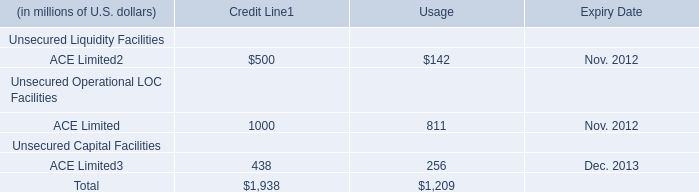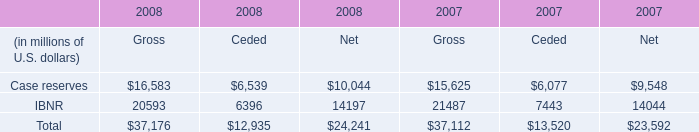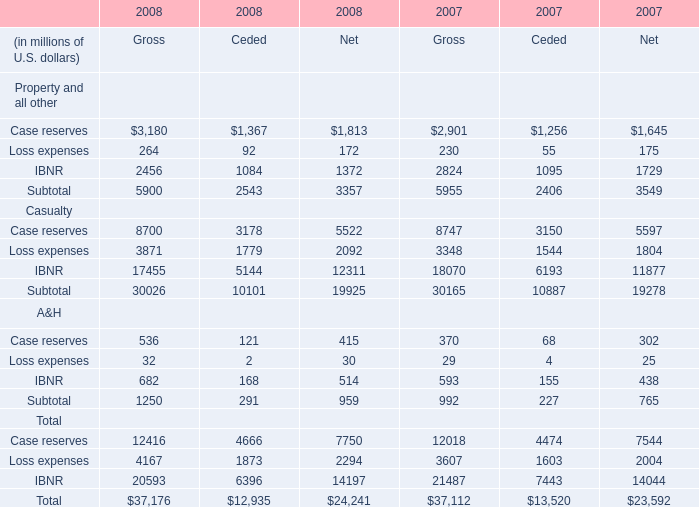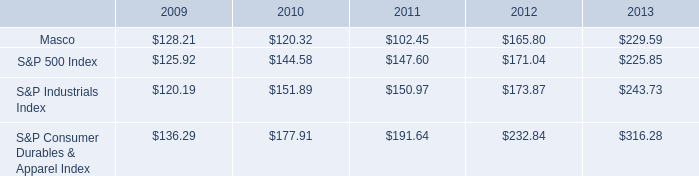What's the growth rate of IBNR of A&H of Gross in 2008? 
Computations: ((682 - 593) / 593)
Answer: 0.15008. 